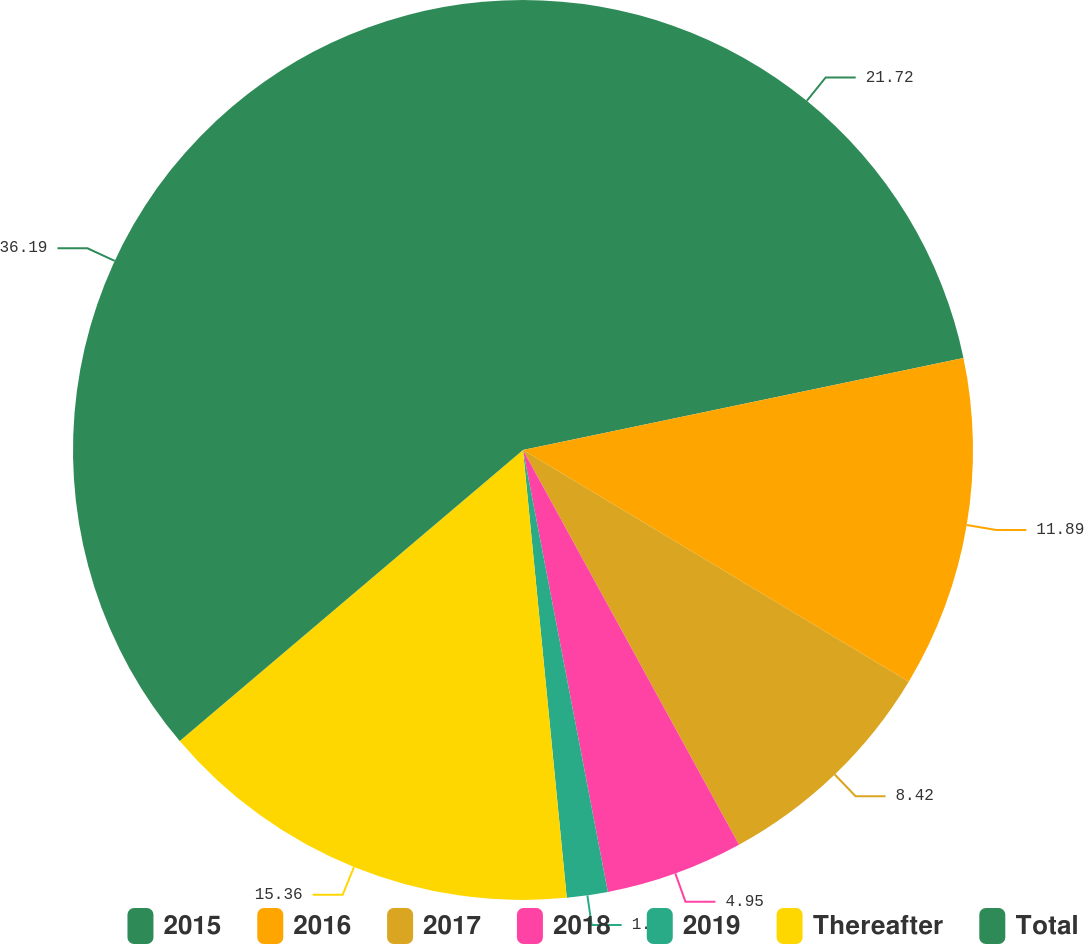Convert chart. <chart><loc_0><loc_0><loc_500><loc_500><pie_chart><fcel>2015<fcel>2016<fcel>2017<fcel>2018<fcel>2019<fcel>Thereafter<fcel>Total<nl><fcel>21.72%<fcel>11.89%<fcel>8.42%<fcel>4.95%<fcel>1.47%<fcel>15.36%<fcel>36.19%<nl></chart> 